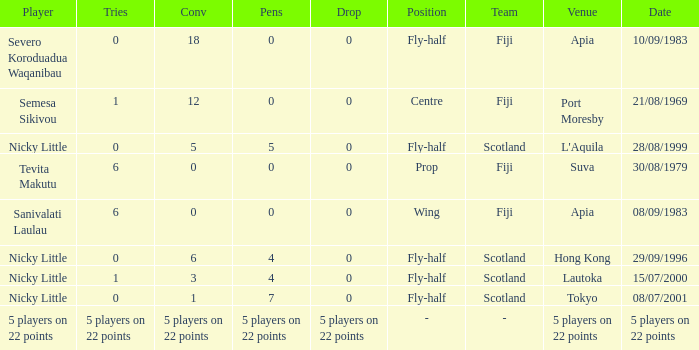How many conversions did Severo Koroduadua Waqanibau have when he has 0 pens? 18.0. 